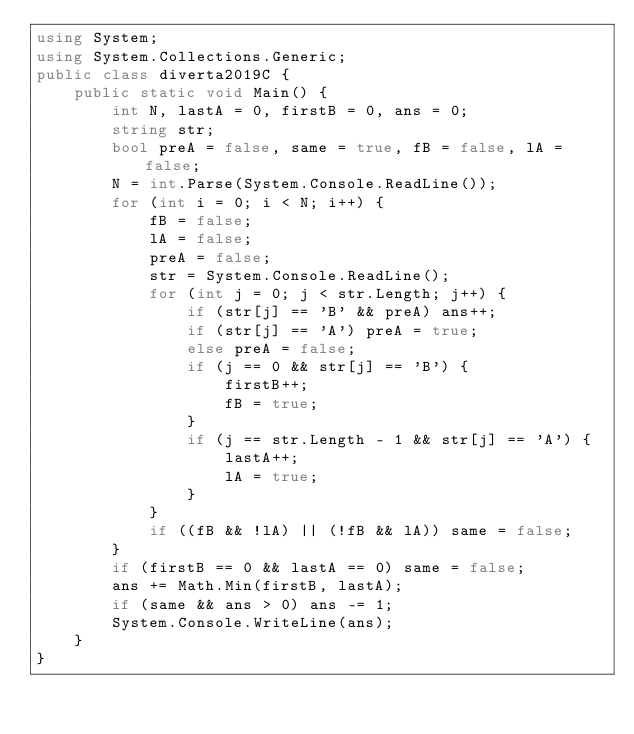<code> <loc_0><loc_0><loc_500><loc_500><_C#_>using System;
using System.Collections.Generic;
public class diverta2019C {
    public static void Main() {
        int N, lastA = 0, firstB = 0, ans = 0;
        string str;
        bool preA = false, same = true, fB = false, lA = false;
        N = int.Parse(System.Console.ReadLine());
        for (int i = 0; i < N; i++) {
            fB = false;
            lA = false;
            preA = false;
            str = System.Console.ReadLine();
            for (int j = 0; j < str.Length; j++) {
                if (str[j] == 'B' && preA) ans++;
                if (str[j] == 'A') preA = true;
                else preA = false;
                if (j == 0 && str[j] == 'B') {
                    firstB++;
                    fB = true;
                }
                if (j == str.Length - 1 && str[j] == 'A') {
                    lastA++;
                    lA = true;
                }
            }
            if ((fB && !lA) || (!fB && lA)) same = false;
        }
        if (firstB == 0 && lastA == 0) same = false;
        ans += Math.Min(firstB, lastA);
        if (same && ans > 0) ans -= 1;
        System.Console.WriteLine(ans);
    }
}</code> 